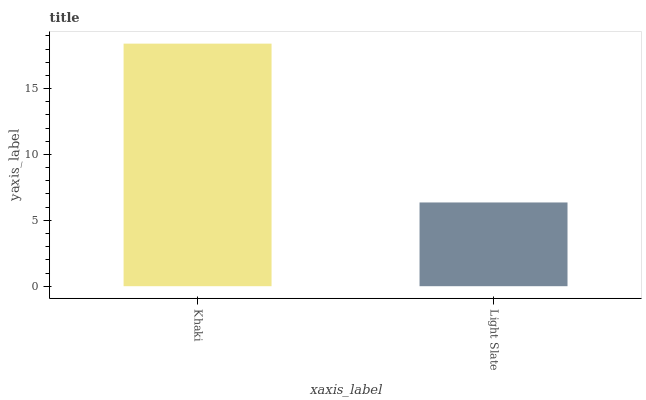Is Light Slate the minimum?
Answer yes or no. Yes. Is Khaki the maximum?
Answer yes or no. Yes. Is Light Slate the maximum?
Answer yes or no. No. Is Khaki greater than Light Slate?
Answer yes or no. Yes. Is Light Slate less than Khaki?
Answer yes or no. Yes. Is Light Slate greater than Khaki?
Answer yes or no. No. Is Khaki less than Light Slate?
Answer yes or no. No. Is Khaki the high median?
Answer yes or no. Yes. Is Light Slate the low median?
Answer yes or no. Yes. Is Light Slate the high median?
Answer yes or no. No. Is Khaki the low median?
Answer yes or no. No. 